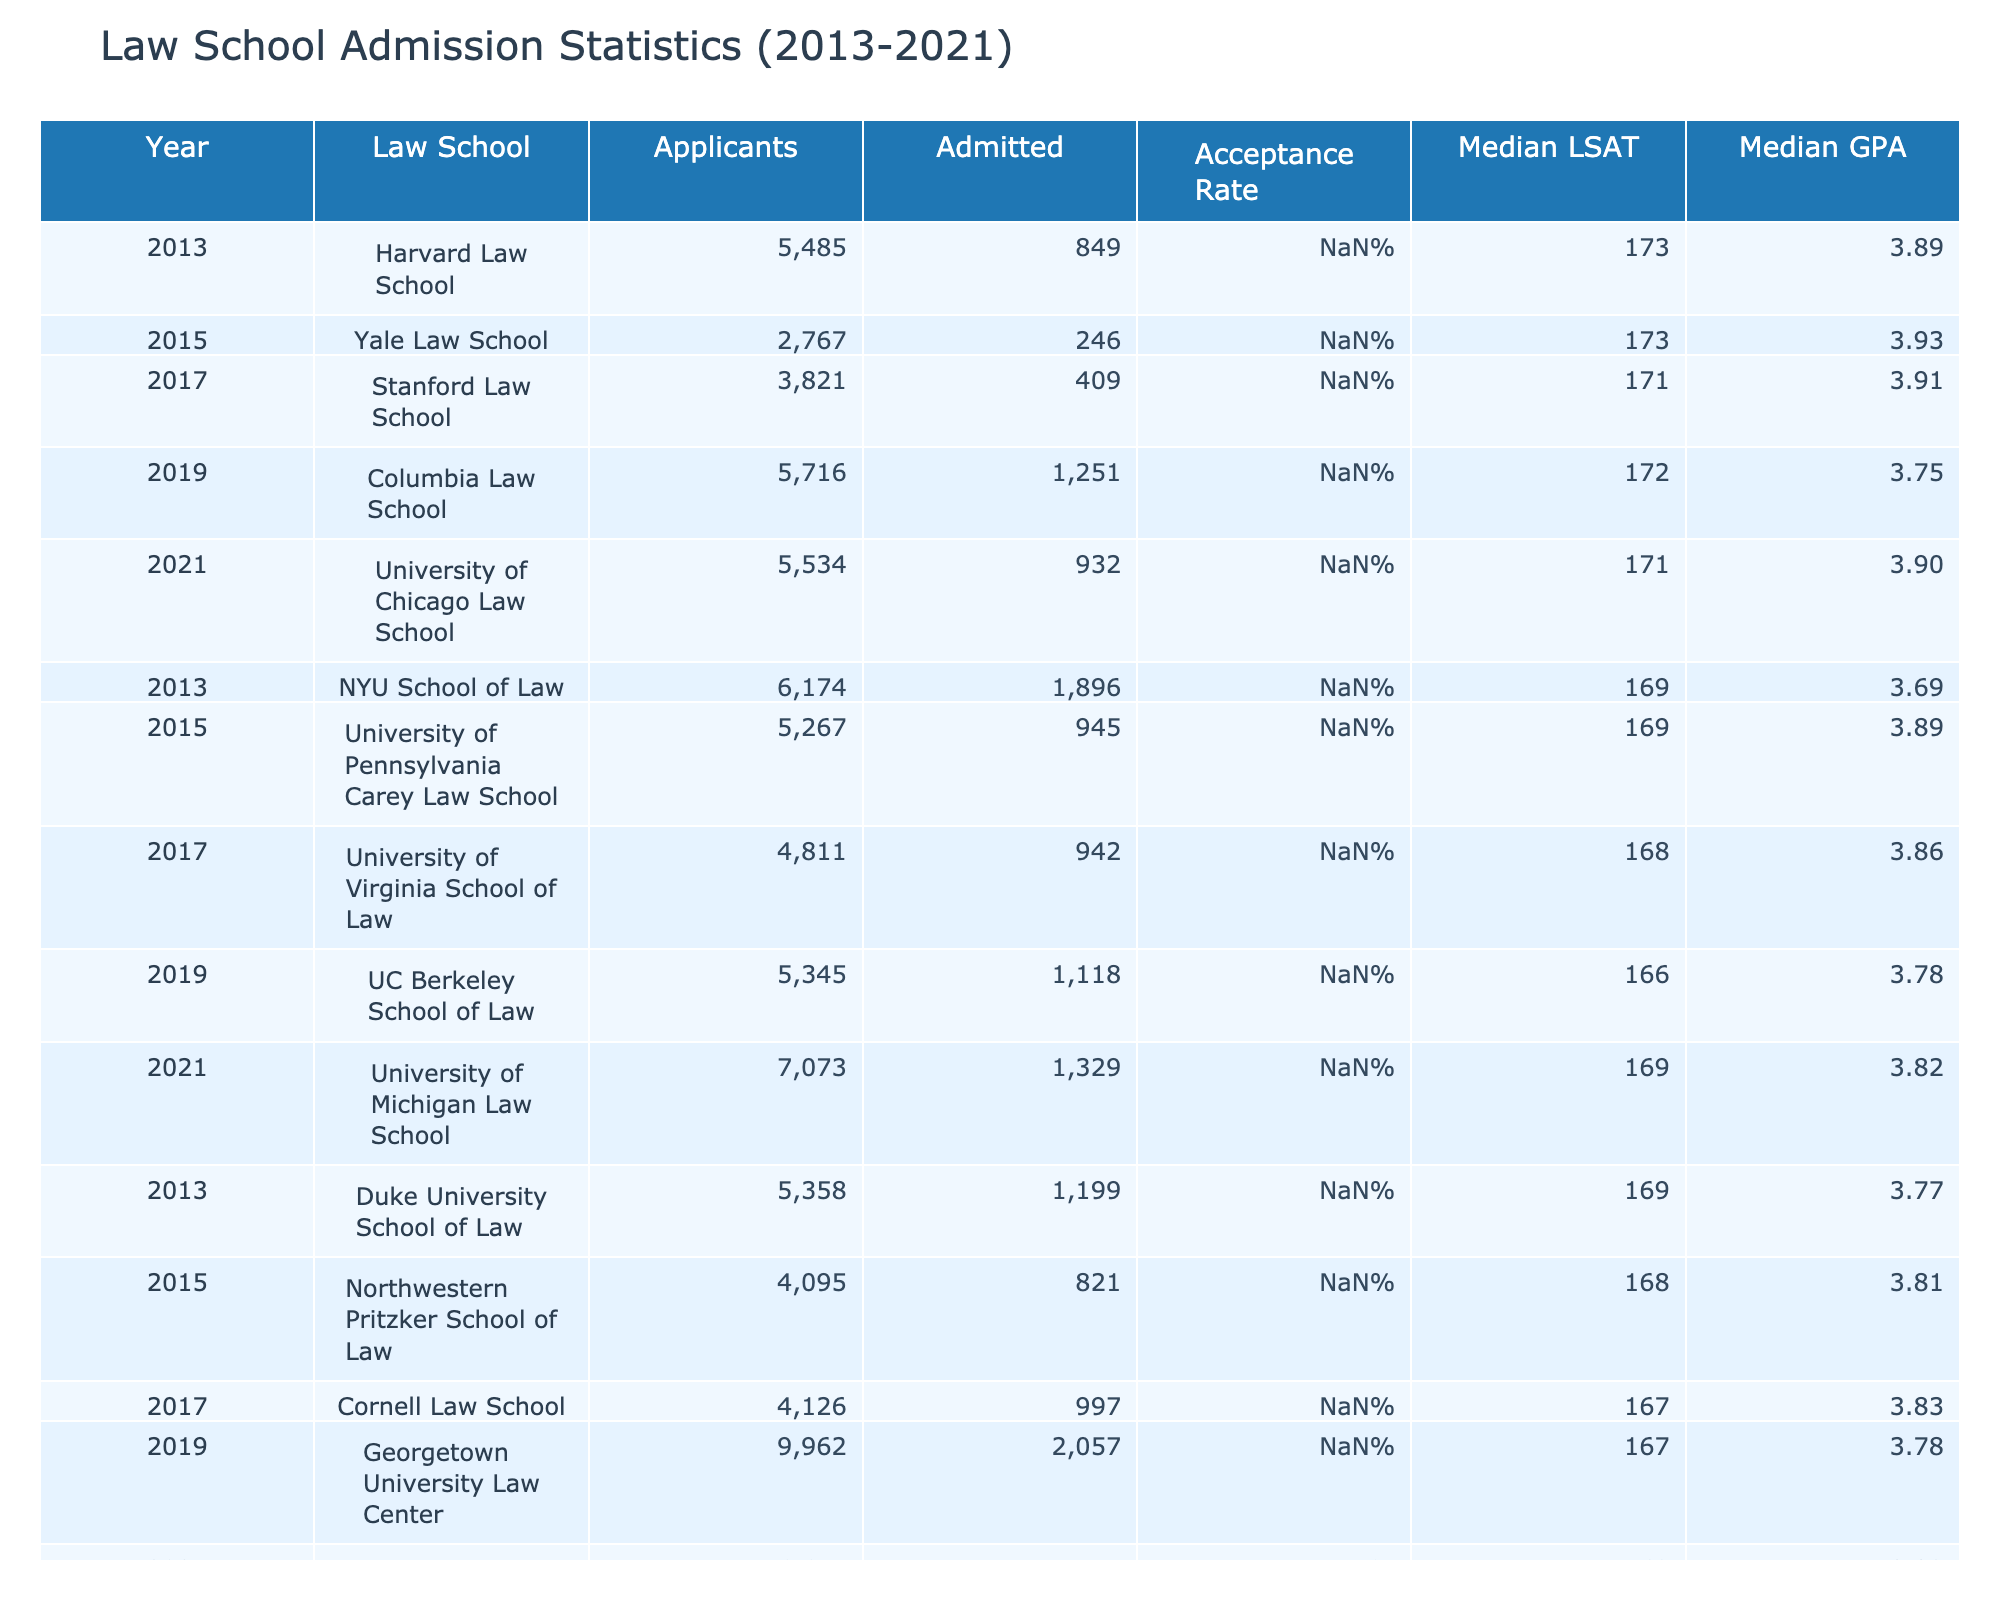What was the acceptance rate for Yale Law School in 2015? The table lists the acceptance rate for each school and year. Looking at Yale Law School for 2015, the acceptance rate is listed as 8.9%.
Answer: 8.9% Which law school had the highest number of applicants in 2021? By comparing the applicant numbers in the 2021 row, University of Michigan Law School had the highest number of applicants at 7073.
Answer: University of Michigan Law School What is the median GPA for Stanford Law School in 2017? The table provides the median GPA for each law school by year. For Stanford Law School in 2017, the median GPA is 3.91.
Answer: 3.91 What is the difference in the number of admitted students between Harvard Law School in 2013 and UC Berkeley School of Law in 2019? Harvard Law School admitted 849 students in 2013 and UC Berkeley Law School admitted 1118 students in 2019. The difference is calculated as 1118 - 849 = 269.
Answer: 269 Which law school had the lowest acceptance rate in 2013? The acceptance rates for 2013 are: Harvard Law School (15.5%), NYU School of Law (30.7%), Duke University School of Law (22.4%). The lowest rate is that of Harvard at 15.5%.
Answer: Harvard Law School What is the average acceptance rate for the law schools listed in 2019? First, we find the acceptance rates for 2019: Columbia (21.9%), UC Berkeley (20.9%), Georgetown (20.6%). The sum is 21.9 + 20.9 + 20.6 = 63.4. To find the average, we divide by 3, yielding 63.4 / 3 = 21.13%.
Answer: 21.13% Did the University of Pennsylvania Carey Law School have a higher median LSAT than Cornell Law School in 2017? The median LSAT for the University of Pennsylvania in 2015 is 169, while for Cornell Law School in 2017 it is 167. Therefore, Pennsylvania's median LSAT is higher.
Answer: Yes Which law school had the highest median LSAT in 2021? The medians for 2021 are: University of Chicago (171), University of Michigan (169), and UCLA (169). The highest median LSAT is 171 from the University of Chicago.
Answer: University of Chicago Law School What is the trend in acceptance rates for Harvard Law School from 2013 to 2021? In 2013, Harvard had an acceptance rate of 15.5%. The data points primarily suggest a relatively steady trend, but require additional context for a detailed trend analysis. Overall, there appears to be no significant change.
Answer: No significant change 